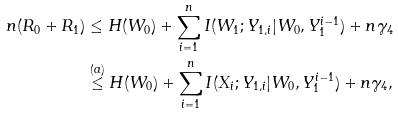Convert formula to latex. <formula><loc_0><loc_0><loc_500><loc_500>n ( R _ { 0 } + R _ { 1 } ) & \leq H ( W _ { 0 } ) + \sum _ { i = 1 } ^ { n } I ( W _ { 1 } ; Y _ { 1 , i } | W _ { 0 } , Y _ { 1 } ^ { i - 1 } ) + n \gamma _ { 4 } \\ & \stackrel { ( a ) } { \leq } H ( W _ { 0 } ) + \sum _ { i = 1 } ^ { n } I ( X _ { i } ; Y _ { 1 , i } | W _ { 0 } , Y _ { 1 } ^ { i - 1 } ) + n \gamma _ { 4 } ,</formula> 